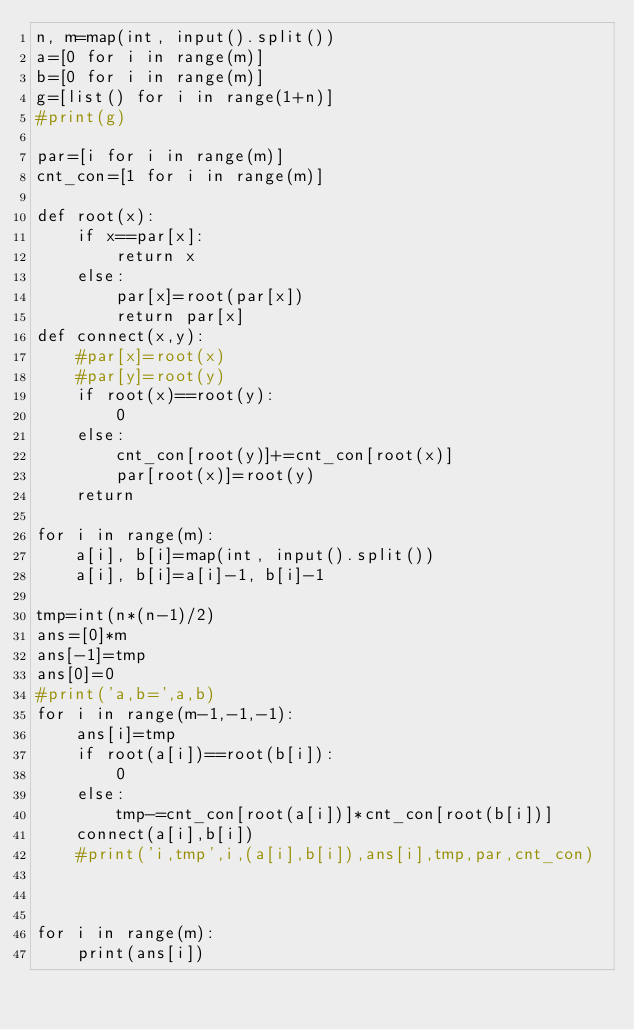<code> <loc_0><loc_0><loc_500><loc_500><_Python_>n, m=map(int, input().split())
a=[0 for i in range(m)]
b=[0 for i in range(m)]
g=[list() for i in range(1+n)]
#print(g)

par=[i for i in range(m)]
cnt_con=[1 for i in range(m)]

def root(x):
    if x==par[x]:
        return x
    else:
        par[x]=root(par[x])
        return par[x]
def connect(x,y):
    #par[x]=root(x)
    #par[y]=root(y)
    if root(x)==root(y):
        0
    else:
        cnt_con[root(y)]+=cnt_con[root(x)]
        par[root(x)]=root(y)      
    return

for i in range(m):
    a[i], b[i]=map(int, input().split())
    a[i], b[i]=a[i]-1, b[i]-1

tmp=int(n*(n-1)/2)
ans=[0]*m
ans[-1]=tmp
ans[0]=0
#print('a,b=',a,b)
for i in range(m-1,-1,-1):
    ans[i]=tmp
    if root(a[i])==root(b[i]):
        0
    else:
        tmp-=cnt_con[root(a[i])]*cnt_con[root(b[i])]
    connect(a[i],b[i])
    #print('i,tmp',i,(a[i],b[i]),ans[i],tmp,par,cnt_con)
    
        
    
for i in range(m):
    print(ans[i])</code> 